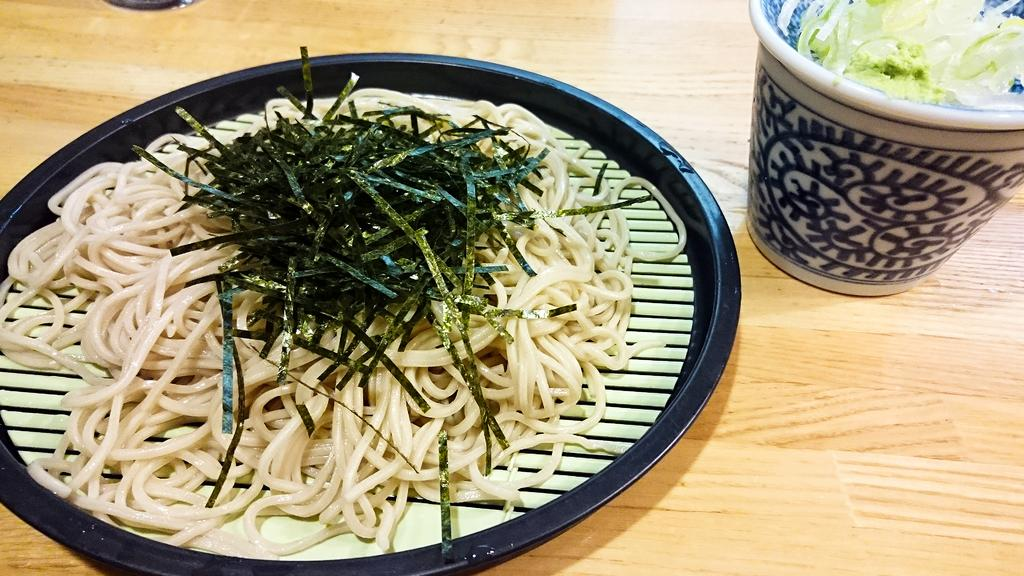What piece of furniture is present in the image? There is a table in the image. What is placed on the table? There is a glass and a plate on the table. What is on the plate? The plate contains noodles and another food item. What is in the glass? The glass contains a food item. What type of paint is being used to decorate the maid's apron in the image? There is no maid or paint present in the image. What type of bread is being served on the plate with the noodles? The plate contains noodles and another food item, but there is no mention of bread in the image. 